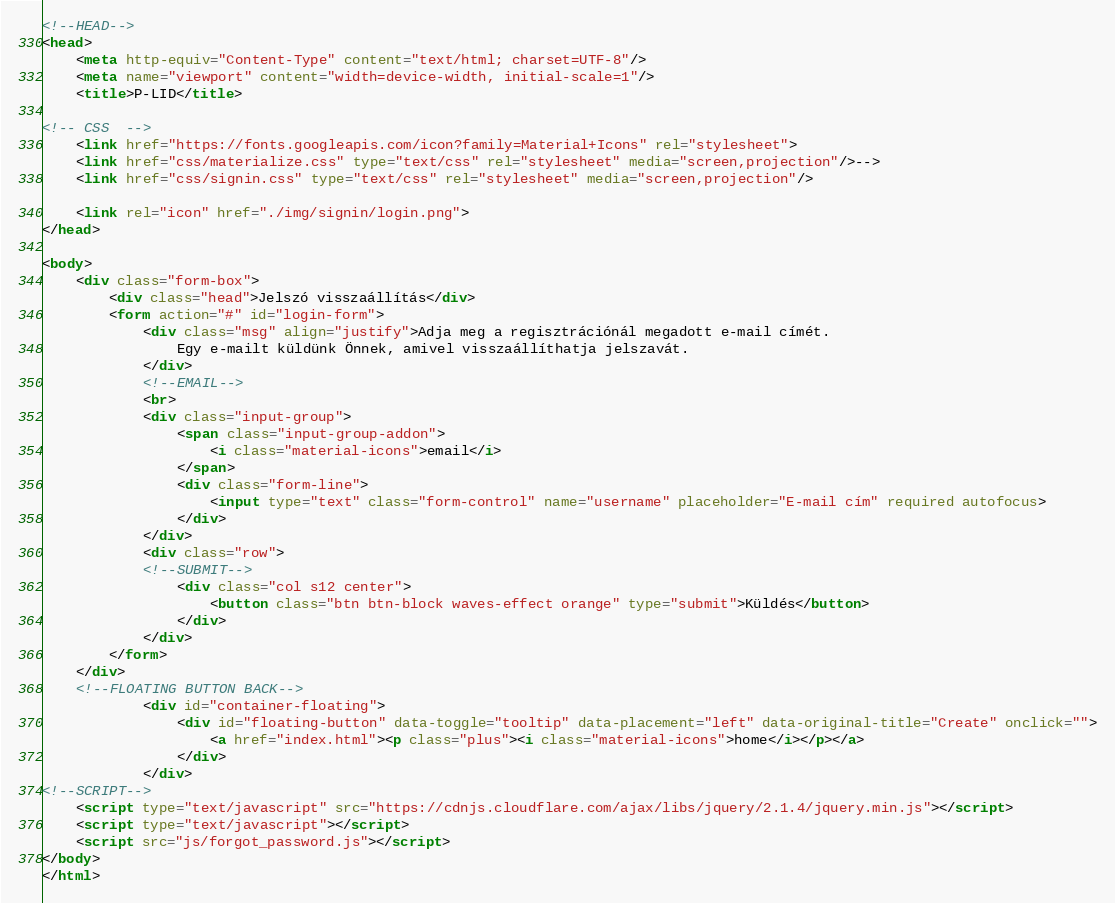<code> <loc_0><loc_0><loc_500><loc_500><_HTML_><!--HEAD-->
<head>
	<meta http-equiv="Content-Type" content="text/html; charset=UTF-8"/>
	<meta name="viewport" content="width=device-width, initial-scale=1"/>
	<title>P-LID</title>

<!-- CSS  -->
	<link href="https://fonts.googleapis.com/icon?family=Material+Icons" rel="stylesheet">
    <link href="css/materialize.css" type="text/css" rel="stylesheet" media="screen,projection"/>-->
	<link href="css/signin.css" type="text/css" rel="stylesheet" media="screen,projection"/>
	
	<link rel="icon" href="./img/signin/login.png">
</head>

<body>
	<div class="form-box">
		<div class="head">Jelszó visszaállítás</div>
		<form action="#" id="login-form">
			<div class="msg" align="justify">Adja meg a regisztrációnál megadott e-mail címét.
				Egy e-mailt küldünk Önnek, amivel visszaállíthatja jelszavát.
			</div>
			<!--EMAIL-->
			<br>
            <div class="input-group">
                <span class="input-group-addon">
                    <i class="material-icons">email</i>
                </span>
                <div class="form-line">
					<input type="text" class="form-control" name="username" placeholder="E-mail cím" required autofocus>
                </div>
            </div>
			<div class="row">
			<!--SUBMIT-->
				<div class="col s12 center">
                    <button class="btn btn-block waves-effect orange" type="submit">Küldés</button>
                </div>
			</div>
		</form>
	</div>
	<!--FLOATING BUTTON BACK-->
			<div id="container-floating">
				<div id="floating-button" data-toggle="tooltip" data-placement="left" data-original-title="Create" onclick="">
					<a href="index.html"><p class="plus"><i class="material-icons">home</i></p></a>
				</div>
			</div>
<!--SCRIPT-->
	<script type="text/javascript" src="https://cdnjs.cloudflare.com/ajax/libs/jquery/2.1.4/jquery.min.js"></script>
	<script type="text/javascript"></script>
	<script src="js/forgot_password.js"></script>
</body>
</html>
</code> 